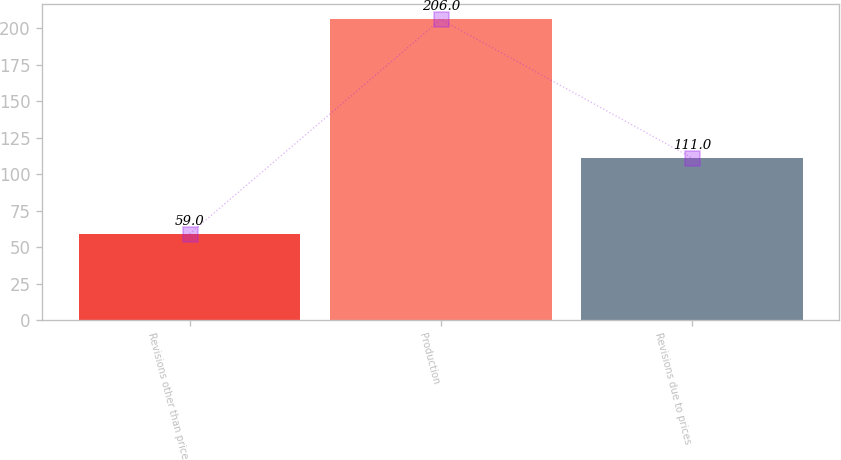<chart> <loc_0><loc_0><loc_500><loc_500><bar_chart><fcel>Revisions other than price<fcel>Production<fcel>Revisions due to prices<nl><fcel>59<fcel>206<fcel>111<nl></chart> 